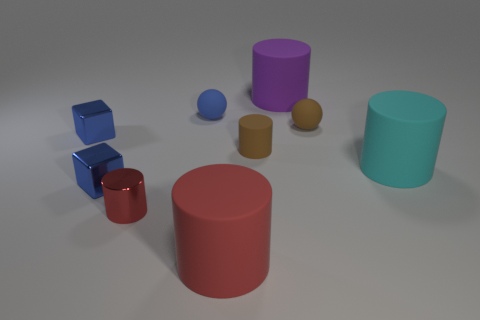What number of small matte things have the same color as the metallic cylinder?
Your answer should be very brief. 0. There is a blue object right of the tiny red metal cylinder behind the large red thing; how big is it?
Your response must be concise. Small. Are there any blue cubes made of the same material as the brown cylinder?
Make the answer very short. No. There is a red cylinder that is the same size as the purple object; what is it made of?
Ensure brevity in your answer.  Rubber. There is a rubber cylinder in front of the metallic cylinder; does it have the same color as the tiny matte object that is to the left of the tiny brown rubber cylinder?
Give a very brief answer. No. Is there a tiny red object left of the matte ball right of the big purple object?
Your answer should be very brief. Yes. There is a blue metal thing that is in front of the brown cylinder; does it have the same shape as the big matte object that is behind the cyan matte thing?
Offer a terse response. No. Is the big thing in front of the tiny red object made of the same material as the blue cube in front of the tiny rubber cylinder?
Make the answer very short. No. There is a tiny cylinder on the left side of the red cylinder in front of the small red thing; what is its material?
Your answer should be very brief. Metal. What is the shape of the brown rubber thing behind the blue cube that is behind the tiny cylinder that is behind the red metallic cylinder?
Keep it short and to the point. Sphere. 